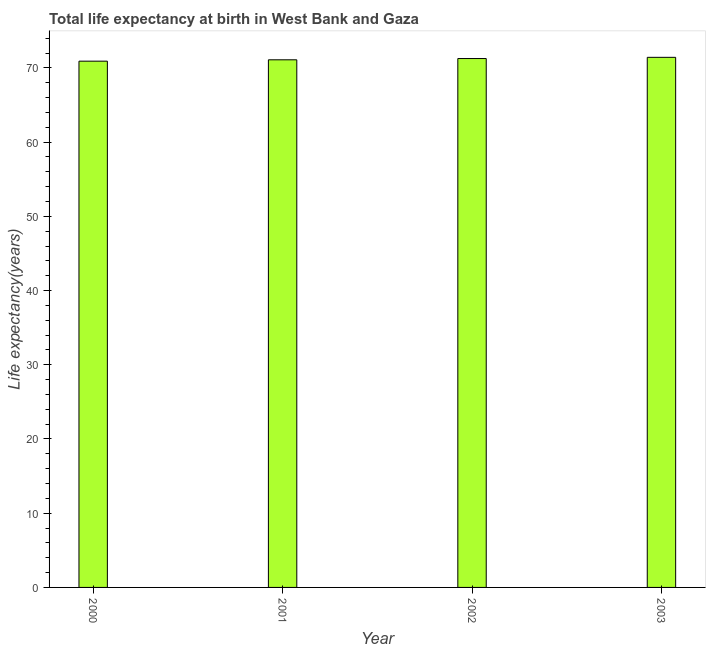Does the graph contain grids?
Your response must be concise. No. What is the title of the graph?
Make the answer very short. Total life expectancy at birth in West Bank and Gaza. What is the label or title of the Y-axis?
Offer a terse response. Life expectancy(years). What is the life expectancy at birth in 2001?
Offer a terse response. 71.09. Across all years, what is the maximum life expectancy at birth?
Provide a short and direct response. 71.42. Across all years, what is the minimum life expectancy at birth?
Keep it short and to the point. 70.91. In which year was the life expectancy at birth maximum?
Your answer should be very brief. 2003. What is the sum of the life expectancy at birth?
Your answer should be compact. 284.68. What is the difference between the life expectancy at birth in 2000 and 2001?
Offer a terse response. -0.18. What is the average life expectancy at birth per year?
Your response must be concise. 71.17. What is the median life expectancy at birth?
Provide a short and direct response. 71.18. What is the difference between the highest and the second highest life expectancy at birth?
Make the answer very short. 0.16. Is the sum of the life expectancy at birth in 2002 and 2003 greater than the maximum life expectancy at birth across all years?
Provide a short and direct response. Yes. What is the difference between the highest and the lowest life expectancy at birth?
Provide a succinct answer. 0.52. In how many years, is the life expectancy at birth greater than the average life expectancy at birth taken over all years?
Your answer should be very brief. 2. How many bars are there?
Offer a very short reply. 4. Are all the bars in the graph horizontal?
Make the answer very short. No. What is the Life expectancy(years) in 2000?
Ensure brevity in your answer.  70.91. What is the Life expectancy(years) of 2001?
Make the answer very short. 71.09. What is the Life expectancy(years) of 2002?
Keep it short and to the point. 71.26. What is the Life expectancy(years) of 2003?
Keep it short and to the point. 71.42. What is the difference between the Life expectancy(years) in 2000 and 2001?
Make the answer very short. -0.18. What is the difference between the Life expectancy(years) in 2000 and 2002?
Provide a short and direct response. -0.35. What is the difference between the Life expectancy(years) in 2000 and 2003?
Keep it short and to the point. -0.52. What is the difference between the Life expectancy(years) in 2001 and 2002?
Provide a succinct answer. -0.17. What is the difference between the Life expectancy(years) in 2001 and 2003?
Your response must be concise. -0.33. What is the difference between the Life expectancy(years) in 2002 and 2003?
Your response must be concise. -0.16. What is the ratio of the Life expectancy(years) in 2000 to that in 2002?
Provide a succinct answer. 0.99. What is the ratio of the Life expectancy(years) in 2000 to that in 2003?
Offer a very short reply. 0.99. What is the ratio of the Life expectancy(years) in 2001 to that in 2002?
Your answer should be compact. 1. What is the ratio of the Life expectancy(years) in 2002 to that in 2003?
Your response must be concise. 1. 